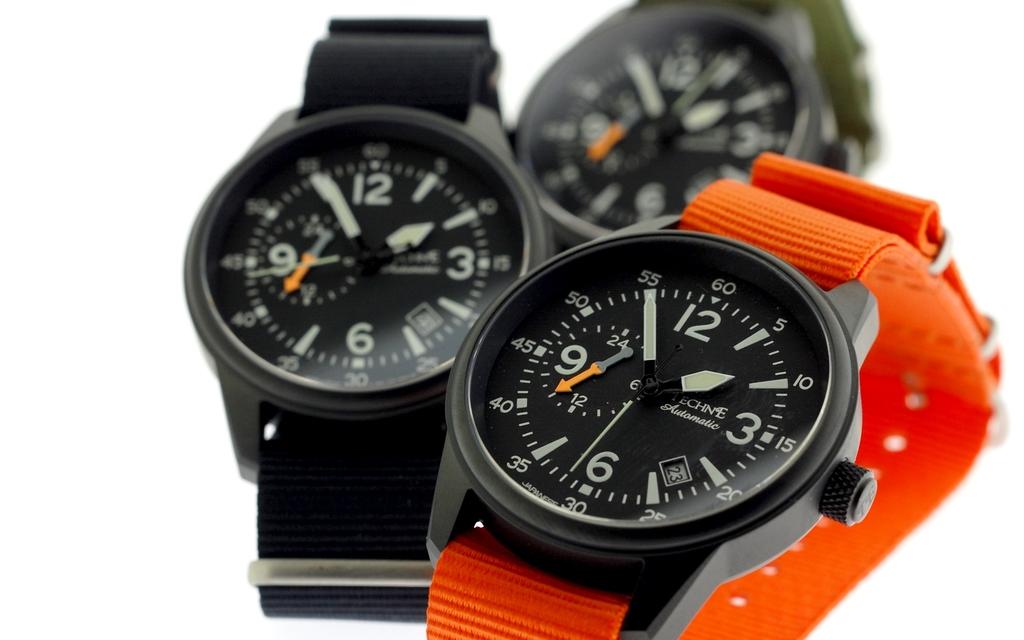What time is it?
Keep it short and to the point. 1:55. What is the brand on the watch?
Your answer should be very brief. Unanswerable. 